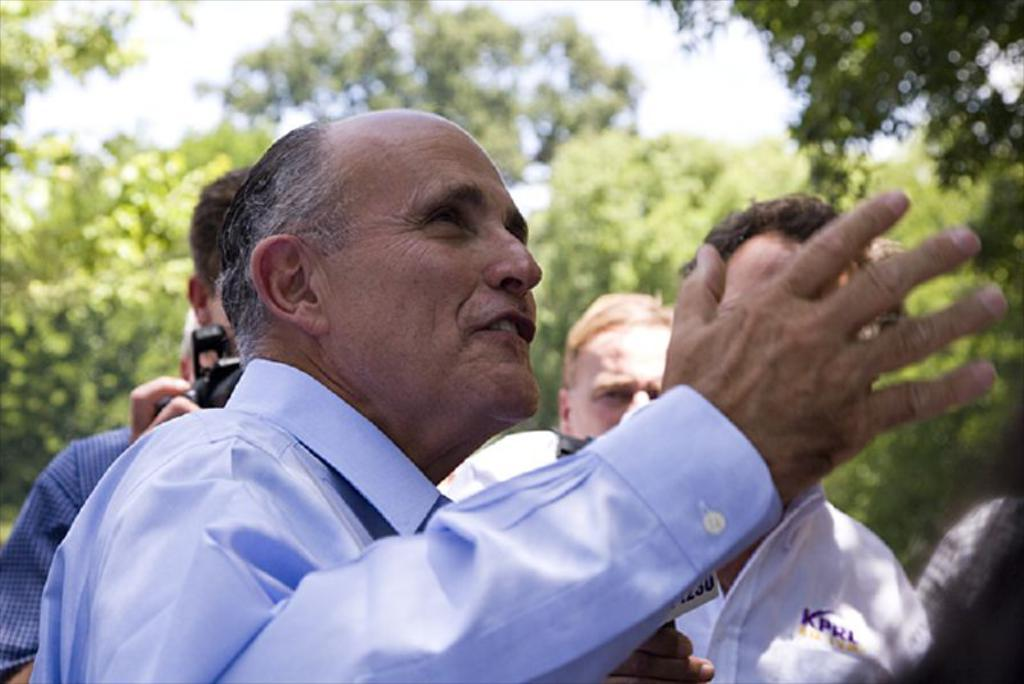How many people are in the image? There is a group of people in the image, but the exact number cannot be determined from the provided facts. What can be seen in the background of the image? There are trees and the sky visible in the background of the image. What color is the heart of the passenger in the image? There is no passenger or heart present in the image. How does the blood flow in the image? There is no blood present in the image. 